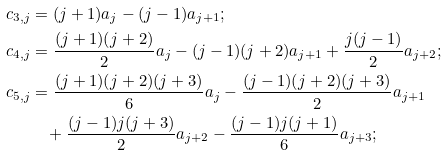Convert formula to latex. <formula><loc_0><loc_0><loc_500><loc_500>c _ { 3 , j } & = ( j + 1 ) a _ { j } - ( j - 1 ) a _ { j + 1 } ; \\ c _ { 4 , j } & = \frac { ( j + 1 ) ( j + 2 ) } { 2 } a _ { j } - ( j - 1 ) ( j + 2 ) a _ { j + 1 } + \frac { j ( j - 1 ) } { 2 } a _ { j + 2 } ; \\ c _ { 5 , j } & = \frac { ( j + 1 ) ( j + 2 ) ( j + 3 ) } { 6 } a _ { j } - \frac { ( j - 1 ) ( j + 2 ) ( j + 3 ) } { 2 } a _ { j + 1 } \\ & \quad + \frac { ( j - 1 ) j ( j + 3 ) } { 2 } a _ { j + 2 } - \frac { ( j - 1 ) j ( j + 1 ) } { 6 } a _ { j + 3 } ;</formula> 